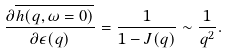<formula> <loc_0><loc_0><loc_500><loc_500>\frac { \partial \overline { h ( q , \omega = 0 ) } } { \partial \epsilon ( q ) } = \frac { 1 } { 1 - J ( q ) } \sim \frac { 1 } { q ^ { 2 } } .</formula> 